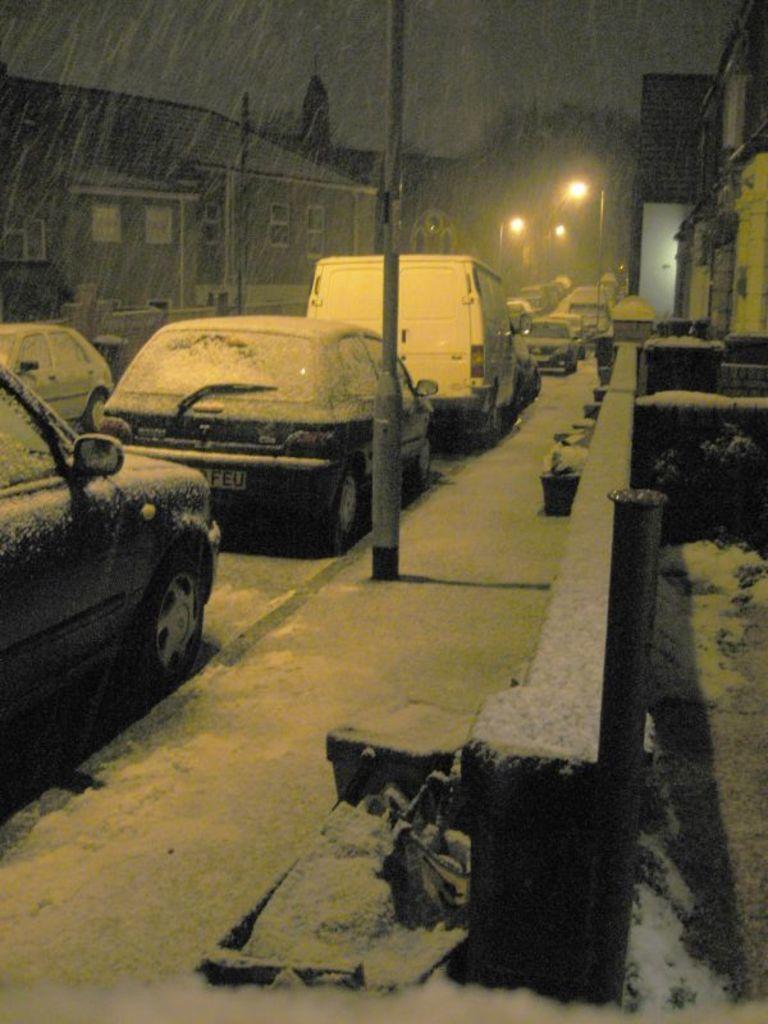Please provide a concise description of this image. In the image we can see there are many vehicles on the road. There are even buildings and light poles. We can even see there may be a tree. Everywhere there is a snow, white in color and there is a snowfall. 